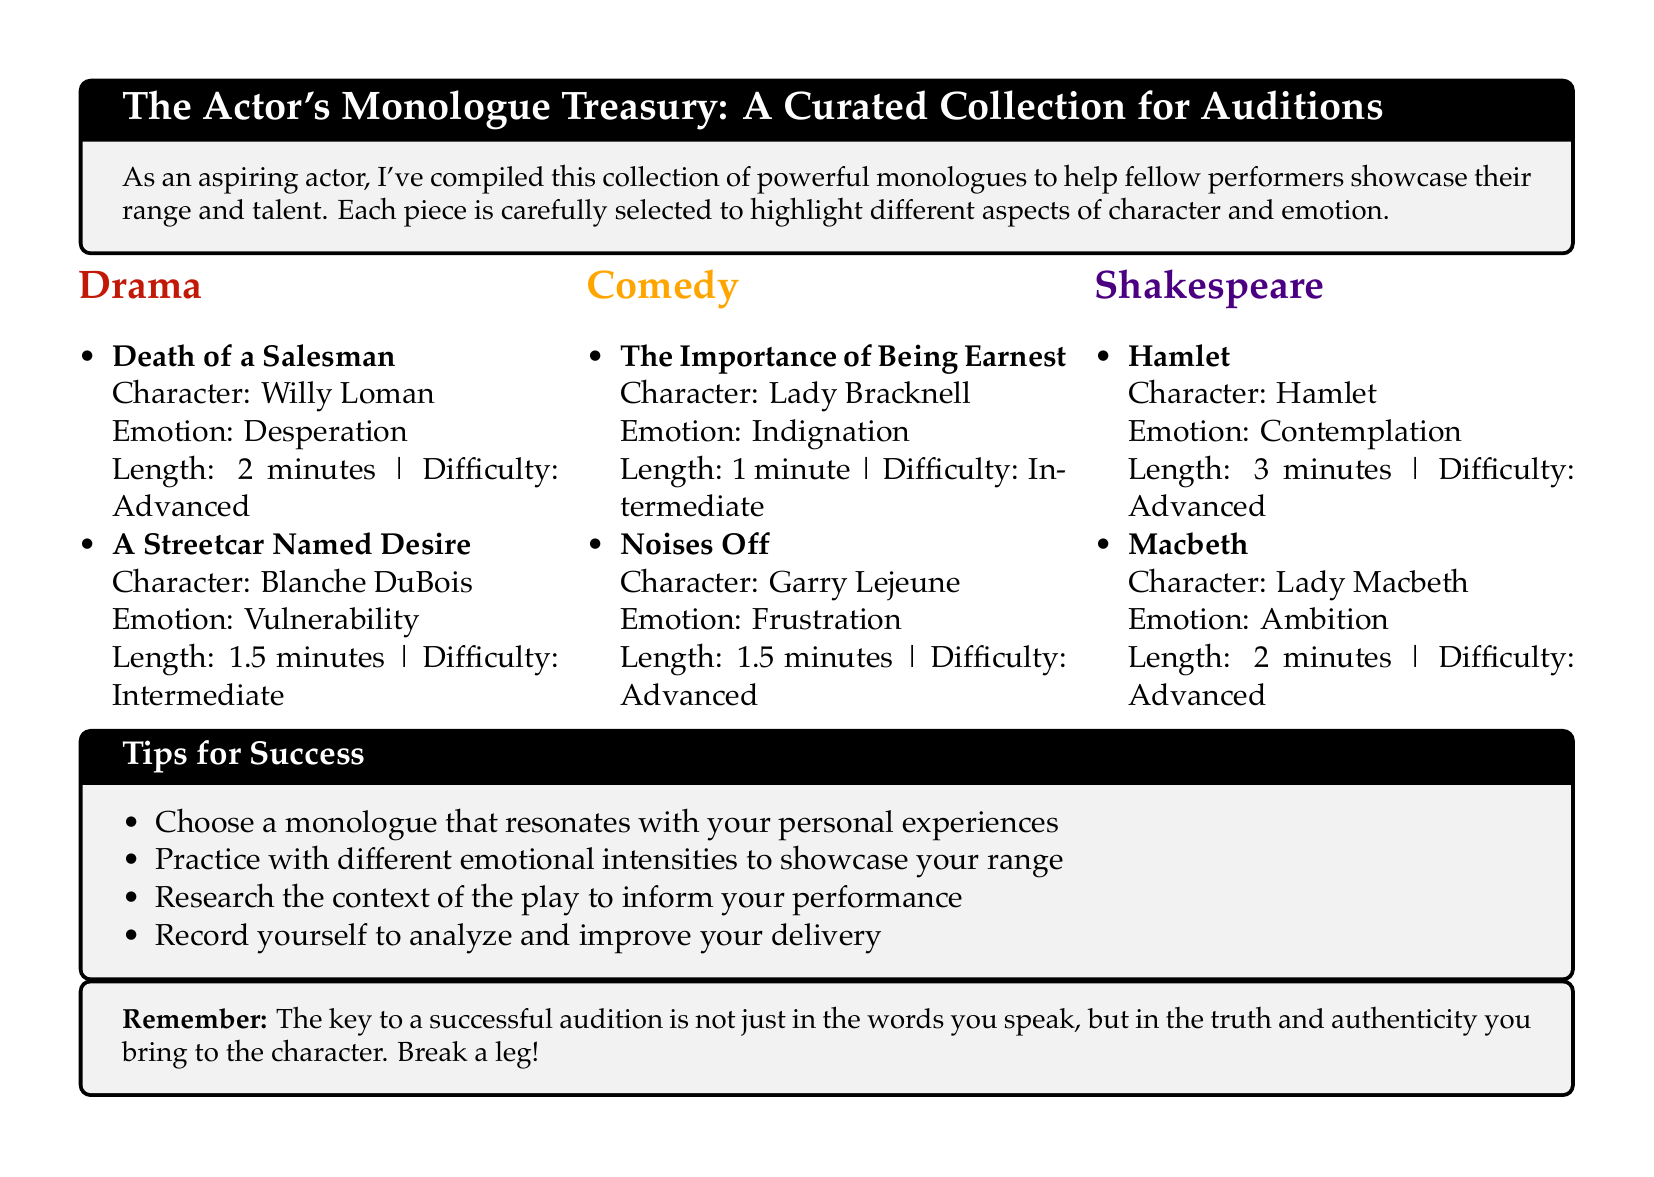What are the emotions displayed in the monologue from "Death of a Salesman"? The emotion displayed in Willy Loman's monologue is desperation.
Answer: desperation How long is the monologue from "A Streetcar Named Desire"? The length of Blanche DuBois's monologue is 1.5 minutes.
Answer: 1.5 minutes Which character from the comedy genre has a monologue about indignation? The character Lady Bracknell from "The Importance of Being Earnest" has a monologue about indignation.
Answer: Lady Bracknell What is the difficulty level of the monologue from "Hamlet"? The difficulty level of Hamlet's monologue is advanced.
Answer: advanced Which play features a character named Garry Lejeune? The play "Noises Off" features the character Garry Lejeune.
Answer: Noises Off What is the emotional range for the monologue from "Macbeth"? The emotion for Lady Macbeth's monologue is ambition.
Answer: ambition How many tips for success are listed in the document? There are four tips for success listed in the document.
Answer: four What is the primary focus of the collection in the document? The primary focus of the collection is to help performers showcase their range and talent.
Answer: showcase their range and talent What character from Shakespeare's works is mentioned with contemplation as an emotion? The character Hamlet is mentioned with contemplation as an emotion.
Answer: Hamlet 